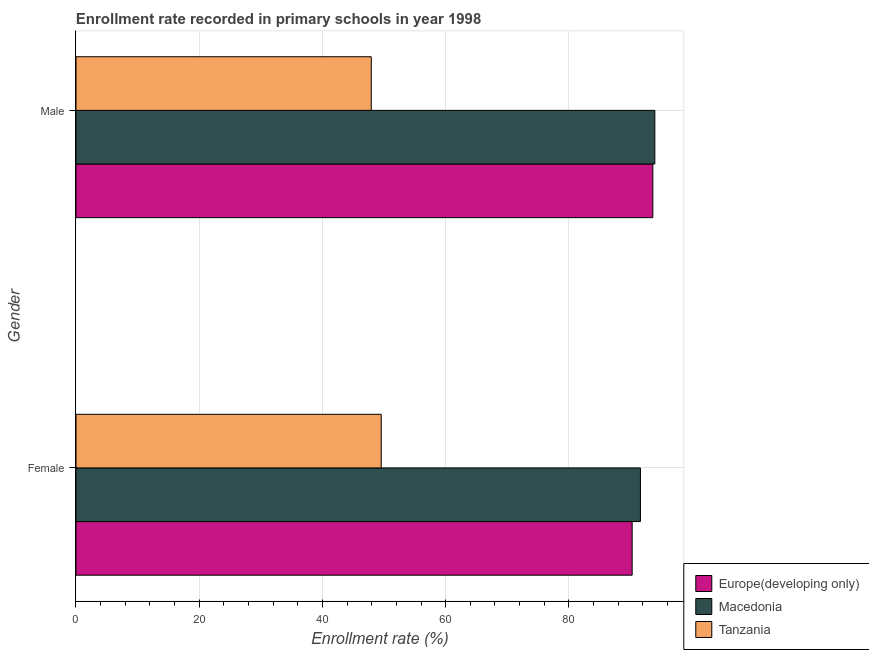How many bars are there on the 2nd tick from the top?
Offer a very short reply. 3. What is the enrollment rate of male students in Europe(developing only)?
Your response must be concise. 93.62. Across all countries, what is the maximum enrollment rate of female students?
Give a very brief answer. 91.61. Across all countries, what is the minimum enrollment rate of male students?
Your answer should be very brief. 47.92. In which country was the enrollment rate of female students maximum?
Ensure brevity in your answer.  Macedonia. In which country was the enrollment rate of male students minimum?
Keep it short and to the point. Tanzania. What is the total enrollment rate of female students in the graph?
Ensure brevity in your answer.  231.41. What is the difference between the enrollment rate of female students in Europe(developing only) and that in Tanzania?
Offer a terse response. 40.73. What is the difference between the enrollment rate of male students in Macedonia and the enrollment rate of female students in Europe(developing only)?
Offer a terse response. 3.68. What is the average enrollment rate of female students per country?
Ensure brevity in your answer.  77.14. What is the difference between the enrollment rate of male students and enrollment rate of female students in Tanzania?
Keep it short and to the point. -1.61. What is the ratio of the enrollment rate of male students in Tanzania to that in Europe(developing only)?
Provide a short and direct response. 0.51. Is the enrollment rate of female students in Europe(developing only) less than that in Tanzania?
Offer a very short reply. No. What does the 2nd bar from the top in Female represents?
Keep it short and to the point. Macedonia. What does the 1st bar from the bottom in Female represents?
Offer a very short reply. Europe(developing only). How many bars are there?
Ensure brevity in your answer.  6. Are all the bars in the graph horizontal?
Your answer should be very brief. Yes. How many countries are there in the graph?
Keep it short and to the point. 3. What is the difference between two consecutive major ticks on the X-axis?
Provide a short and direct response. 20. Are the values on the major ticks of X-axis written in scientific E-notation?
Your answer should be compact. No. Where does the legend appear in the graph?
Ensure brevity in your answer.  Bottom right. How many legend labels are there?
Your response must be concise. 3. How are the legend labels stacked?
Offer a terse response. Vertical. What is the title of the graph?
Make the answer very short. Enrollment rate recorded in primary schools in year 1998. What is the label or title of the X-axis?
Ensure brevity in your answer.  Enrollment rate (%). What is the Enrollment rate (%) in Europe(developing only) in Female?
Your answer should be compact. 90.26. What is the Enrollment rate (%) in Macedonia in Female?
Ensure brevity in your answer.  91.61. What is the Enrollment rate (%) of Tanzania in Female?
Your response must be concise. 49.54. What is the Enrollment rate (%) of Europe(developing only) in Male?
Make the answer very short. 93.62. What is the Enrollment rate (%) in Macedonia in Male?
Your answer should be very brief. 93.94. What is the Enrollment rate (%) of Tanzania in Male?
Offer a terse response. 47.92. Across all Gender, what is the maximum Enrollment rate (%) of Europe(developing only)?
Offer a terse response. 93.62. Across all Gender, what is the maximum Enrollment rate (%) of Macedonia?
Your answer should be compact. 93.94. Across all Gender, what is the maximum Enrollment rate (%) of Tanzania?
Give a very brief answer. 49.54. Across all Gender, what is the minimum Enrollment rate (%) in Europe(developing only)?
Make the answer very short. 90.26. Across all Gender, what is the minimum Enrollment rate (%) of Macedonia?
Offer a terse response. 91.61. Across all Gender, what is the minimum Enrollment rate (%) of Tanzania?
Offer a terse response. 47.92. What is the total Enrollment rate (%) of Europe(developing only) in the graph?
Keep it short and to the point. 183.88. What is the total Enrollment rate (%) of Macedonia in the graph?
Offer a terse response. 185.55. What is the total Enrollment rate (%) in Tanzania in the graph?
Make the answer very short. 97.46. What is the difference between the Enrollment rate (%) of Europe(developing only) in Female and that in Male?
Provide a succinct answer. -3.35. What is the difference between the Enrollment rate (%) in Macedonia in Female and that in Male?
Keep it short and to the point. -2.34. What is the difference between the Enrollment rate (%) of Tanzania in Female and that in Male?
Keep it short and to the point. 1.61. What is the difference between the Enrollment rate (%) of Europe(developing only) in Female and the Enrollment rate (%) of Macedonia in Male?
Provide a succinct answer. -3.68. What is the difference between the Enrollment rate (%) in Europe(developing only) in Female and the Enrollment rate (%) in Tanzania in Male?
Your answer should be compact. 42.34. What is the difference between the Enrollment rate (%) in Macedonia in Female and the Enrollment rate (%) in Tanzania in Male?
Offer a terse response. 43.68. What is the average Enrollment rate (%) in Europe(developing only) per Gender?
Offer a very short reply. 91.94. What is the average Enrollment rate (%) of Macedonia per Gender?
Provide a succinct answer. 92.78. What is the average Enrollment rate (%) in Tanzania per Gender?
Offer a very short reply. 48.73. What is the difference between the Enrollment rate (%) in Europe(developing only) and Enrollment rate (%) in Macedonia in Female?
Offer a very short reply. -1.34. What is the difference between the Enrollment rate (%) of Europe(developing only) and Enrollment rate (%) of Tanzania in Female?
Keep it short and to the point. 40.73. What is the difference between the Enrollment rate (%) of Macedonia and Enrollment rate (%) of Tanzania in Female?
Provide a succinct answer. 42.07. What is the difference between the Enrollment rate (%) in Europe(developing only) and Enrollment rate (%) in Macedonia in Male?
Provide a succinct answer. -0.33. What is the difference between the Enrollment rate (%) of Europe(developing only) and Enrollment rate (%) of Tanzania in Male?
Your answer should be very brief. 45.69. What is the difference between the Enrollment rate (%) in Macedonia and Enrollment rate (%) in Tanzania in Male?
Your response must be concise. 46.02. What is the ratio of the Enrollment rate (%) of Europe(developing only) in Female to that in Male?
Provide a short and direct response. 0.96. What is the ratio of the Enrollment rate (%) of Macedonia in Female to that in Male?
Provide a succinct answer. 0.98. What is the ratio of the Enrollment rate (%) of Tanzania in Female to that in Male?
Make the answer very short. 1.03. What is the difference between the highest and the second highest Enrollment rate (%) in Europe(developing only)?
Give a very brief answer. 3.35. What is the difference between the highest and the second highest Enrollment rate (%) of Macedonia?
Provide a short and direct response. 2.34. What is the difference between the highest and the second highest Enrollment rate (%) of Tanzania?
Provide a short and direct response. 1.61. What is the difference between the highest and the lowest Enrollment rate (%) of Europe(developing only)?
Give a very brief answer. 3.35. What is the difference between the highest and the lowest Enrollment rate (%) in Macedonia?
Offer a very short reply. 2.34. What is the difference between the highest and the lowest Enrollment rate (%) in Tanzania?
Ensure brevity in your answer.  1.61. 